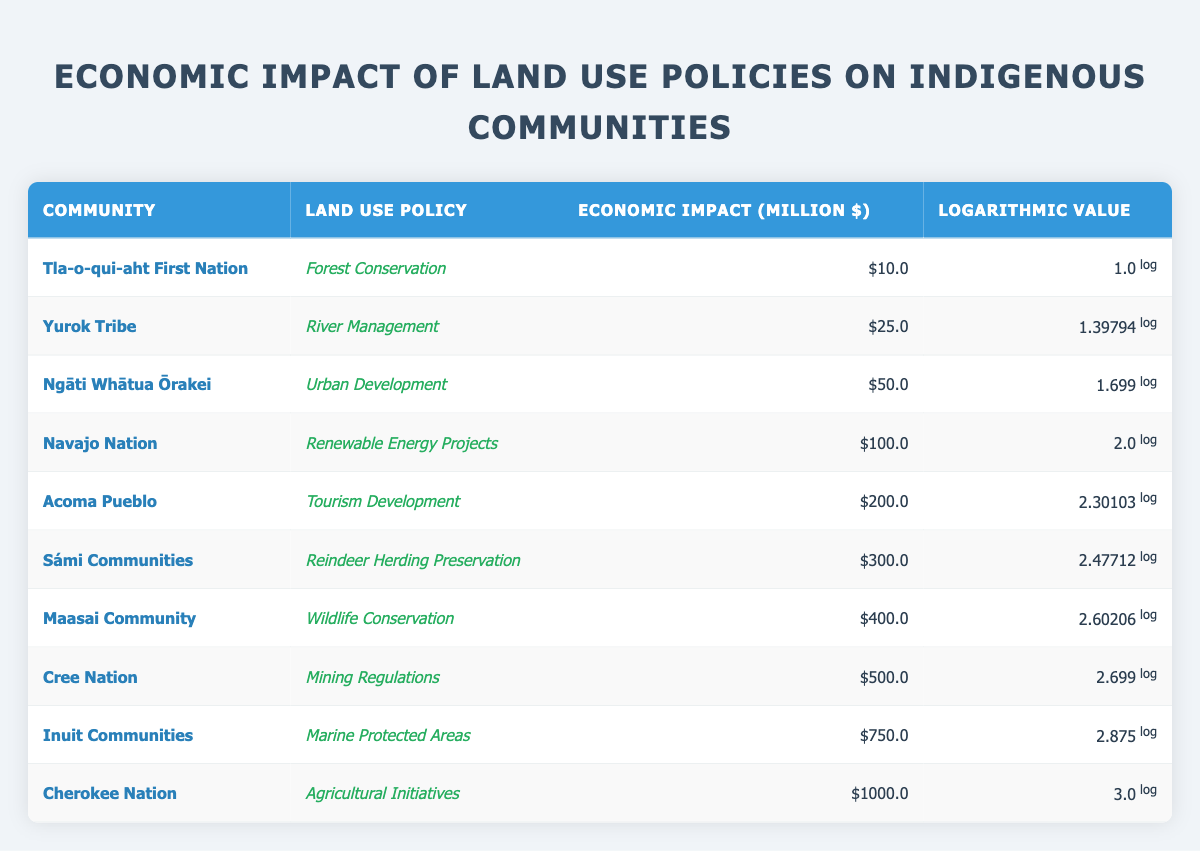What is the economic impact reported for the Tla-o-qui-aht First Nation? The economic impact for the Tla-o-qui-aht First Nation is listed in the table under the economic impact column. Referring to the table, it is 10.0 million dollars.
Answer: 10.0 million dollars Which community has the highest economic impact from land use policies? To determine this, I compare the economic impact values across all communities in the table. The highest value listed is for the Cherokee Nation with an economic impact of 1000.0 million dollars.
Answer: Cherokee Nation What is the average economic impact for all communities listed? First, I add up all the economic impact values: 10.0 + 25.0 + 50.0 + 100.0 + 200.0 + 300.0 + 400.0 + 500.0 + 750.0 + 1000.0 = 3345.0. Then, I count the number of communities, which is 10. The average is calculated by dividing the total by the number of communities: 3345.0 / 10 = 334.5 million dollars.
Answer: 334.5 million dollars Does the Sámi Communities' economic impact exceed that of Acoma Pueblo? I compare the economic impacts for both communities as per the table. The economic impact for Sámi Communities is 300.0 million dollars, whereas for Acoma Pueblo it is 200.0 million dollars. Since 300.0 is greater than 200.0, the statement is true.
Answer: Yes What is the difference in economic impact between the Inuit Communities and the Yurok Tribe? The economic impact for Inuit Communities is 750.0 million dollars and for Yurok Tribe it is 25.0 million dollars. The difference is calculated by subtracting the Yurok Tribe's impact from the Inuit Communities' impact: 750.0 - 25.0 = 725.0 million dollars.
Answer: 725.0 million dollars 